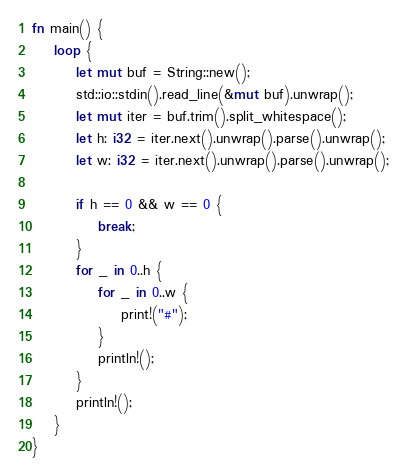Convert code to text. <code><loc_0><loc_0><loc_500><loc_500><_Rust_>fn main() {
    loop {
        let mut buf = String::new();
        std::io::stdin().read_line(&mut buf).unwrap();
        let mut iter = buf.trim().split_whitespace();
        let h: i32 = iter.next().unwrap().parse().unwrap();
        let w: i32 = iter.next().unwrap().parse().unwrap();

        if h == 0 && w == 0 {
            break;
        }
        for _ in 0..h {
            for _ in 0..w {
                print!("#");
            }
            println!();
        }
        println!();
    }
}

</code> 